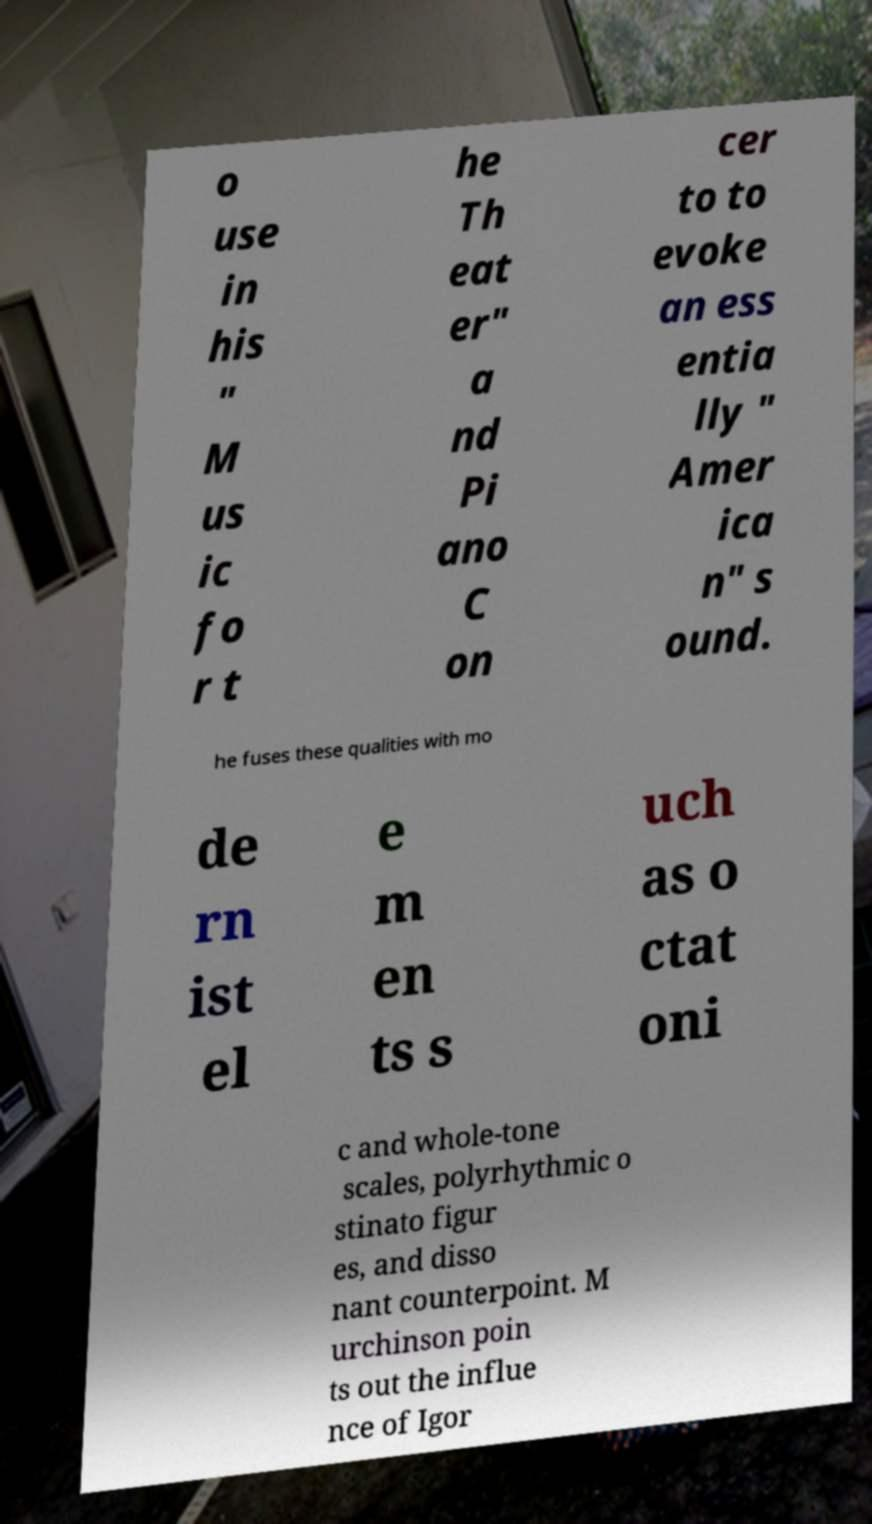Could you extract and type out the text from this image? o use in his " M us ic fo r t he Th eat er" a nd Pi ano C on cer to to evoke an ess entia lly " Amer ica n" s ound. he fuses these qualities with mo de rn ist el e m en ts s uch as o ctat oni c and whole-tone scales, polyrhythmic o stinato figur es, and disso nant counterpoint. M urchinson poin ts out the influe nce of Igor 